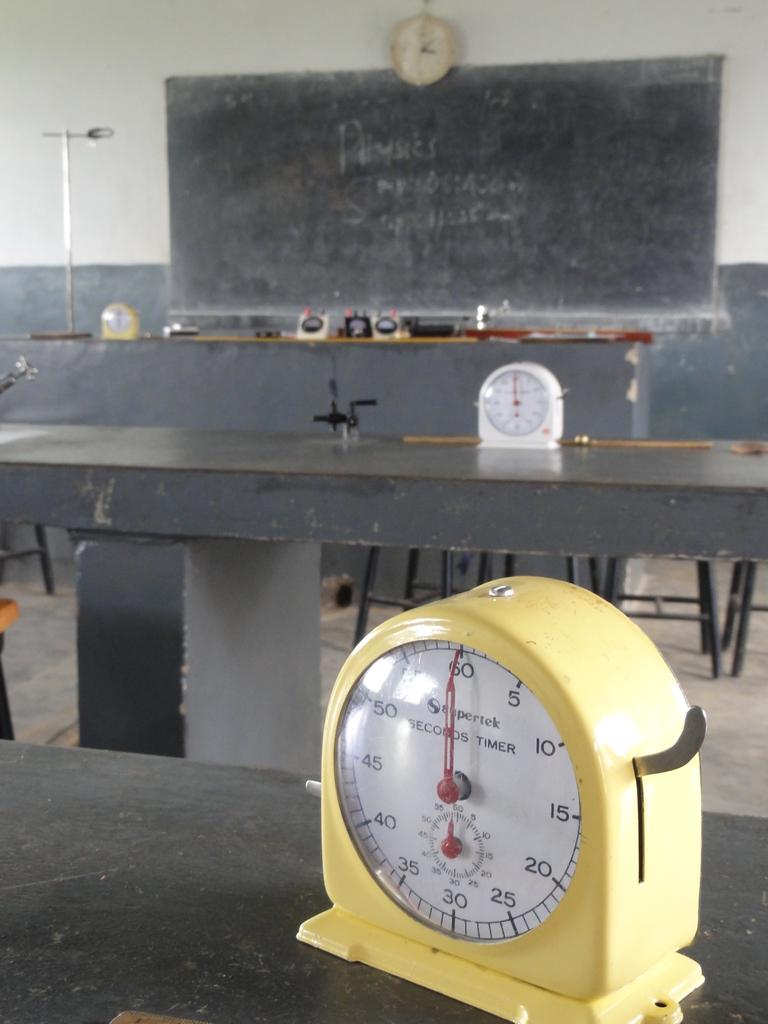What is the timer at?
Provide a succinct answer. 60. What is the time in the wall clock?
Provide a succinct answer. 3:07. 